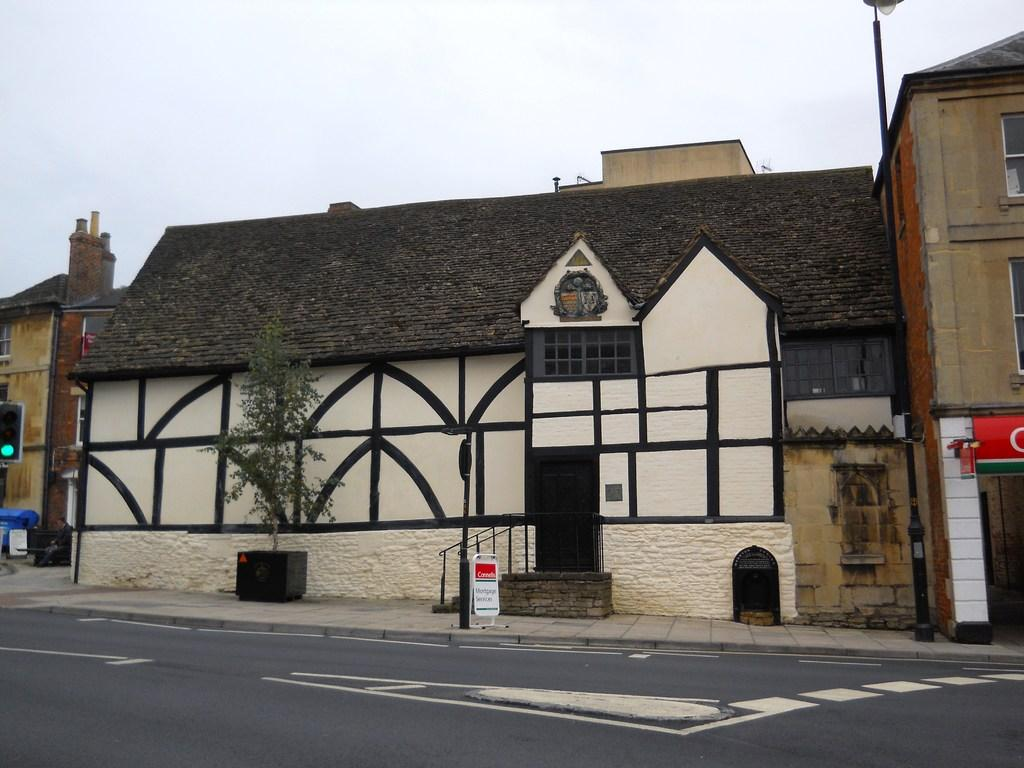What type of structure is present in the image? There is a building in the image. What feature of the building is mentioned in the facts? The building has windows. What else can be seen in the image besides the building? There is a road, a plant pot, a pole, a board, and stairs visible in the image. What is the condition of the road in the image? White lines are visible on the road. What part of the natural environment is visible in the image? The sky is visible in the image. What type of lumber is being used to construct the building in the image? There is no information about the type of lumber used to construct the building in the image. What color is the shirt worn by the person standing next to the building? There is no person or shirt visible in the image. 